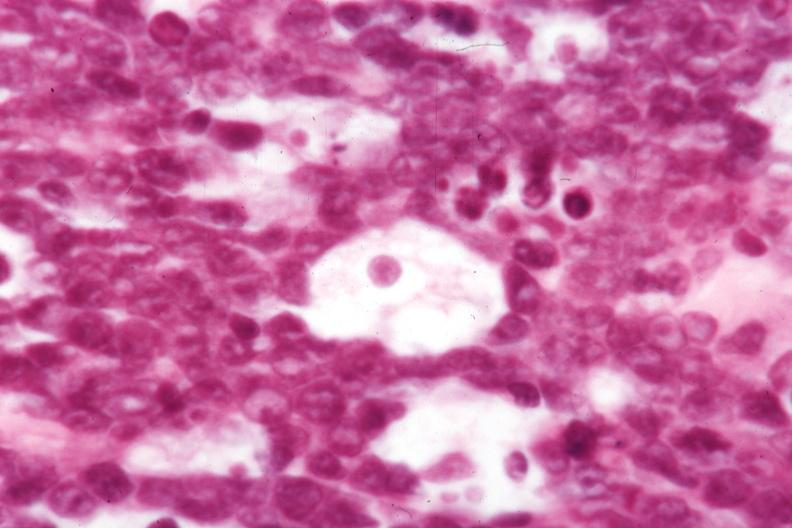s lymph node present?
Answer the question using a single word or phrase. Yes 